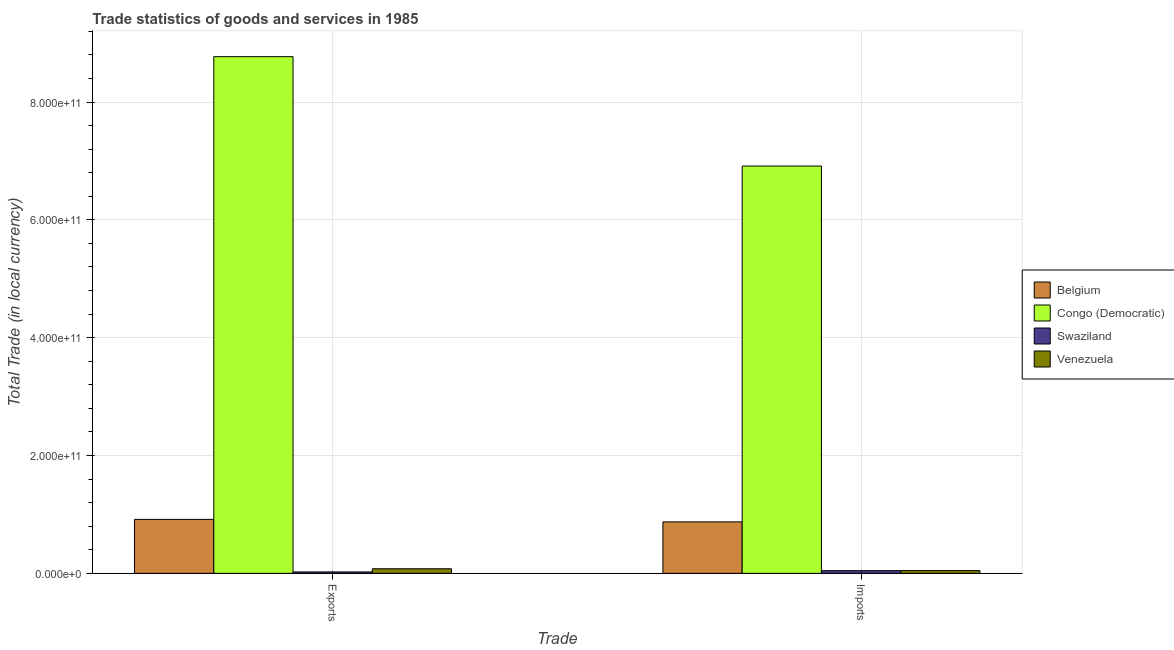How many different coloured bars are there?
Give a very brief answer. 4. How many bars are there on the 2nd tick from the right?
Your answer should be compact. 4. What is the label of the 2nd group of bars from the left?
Your answer should be compact. Imports. What is the imports of goods and services in Swaziland?
Keep it short and to the point. 4.54e+09. Across all countries, what is the maximum imports of goods and services?
Ensure brevity in your answer.  6.91e+11. Across all countries, what is the minimum imports of goods and services?
Offer a terse response. 4.54e+09. In which country was the export of goods and services maximum?
Provide a succinct answer. Congo (Democratic). In which country was the export of goods and services minimum?
Your answer should be compact. Swaziland. What is the total imports of goods and services in the graph?
Offer a terse response. 7.88e+11. What is the difference between the imports of goods and services in Venezuela and that in Swaziland?
Ensure brevity in your answer.  9.42e+07. What is the difference between the export of goods and services in Venezuela and the imports of goods and services in Belgium?
Offer a very short reply. -7.96e+1. What is the average imports of goods and services per country?
Keep it short and to the point. 1.97e+11. What is the difference between the export of goods and services and imports of goods and services in Congo (Democratic)?
Give a very brief answer. 1.86e+11. What is the ratio of the export of goods and services in Belgium to that in Congo (Democratic)?
Provide a short and direct response. 0.1. Is the imports of goods and services in Congo (Democratic) less than that in Belgium?
Provide a succinct answer. No. In how many countries, is the export of goods and services greater than the average export of goods and services taken over all countries?
Provide a short and direct response. 1. What does the 1st bar from the left in Imports represents?
Make the answer very short. Belgium. What does the 1st bar from the right in Exports represents?
Your response must be concise. Venezuela. How many bars are there?
Provide a succinct answer. 8. Are all the bars in the graph horizontal?
Your answer should be compact. No. How many countries are there in the graph?
Give a very brief answer. 4. What is the difference between two consecutive major ticks on the Y-axis?
Make the answer very short. 2.00e+11. Does the graph contain any zero values?
Offer a terse response. No. Does the graph contain grids?
Make the answer very short. Yes. How are the legend labels stacked?
Give a very brief answer. Vertical. What is the title of the graph?
Your answer should be very brief. Trade statistics of goods and services in 1985. Does "Latvia" appear as one of the legend labels in the graph?
Ensure brevity in your answer.  No. What is the label or title of the X-axis?
Offer a terse response. Trade. What is the label or title of the Y-axis?
Keep it short and to the point. Total Trade (in local currency). What is the Total Trade (in local currency) of Belgium in Exports?
Provide a short and direct response. 9.15e+1. What is the Total Trade (in local currency) in Congo (Democratic) in Exports?
Keep it short and to the point. 8.77e+11. What is the Total Trade (in local currency) in Swaziland in Exports?
Keep it short and to the point. 2.37e+09. What is the Total Trade (in local currency) in Venezuela in Exports?
Keep it short and to the point. 7.75e+09. What is the Total Trade (in local currency) in Belgium in Imports?
Make the answer very short. 8.74e+1. What is the Total Trade (in local currency) in Congo (Democratic) in Imports?
Your answer should be very brief. 6.91e+11. What is the Total Trade (in local currency) in Swaziland in Imports?
Provide a short and direct response. 4.54e+09. What is the Total Trade (in local currency) in Venezuela in Imports?
Provide a succinct answer. 4.63e+09. Across all Trade, what is the maximum Total Trade (in local currency) in Belgium?
Your response must be concise. 9.15e+1. Across all Trade, what is the maximum Total Trade (in local currency) in Congo (Democratic)?
Provide a short and direct response. 8.77e+11. Across all Trade, what is the maximum Total Trade (in local currency) of Swaziland?
Ensure brevity in your answer.  4.54e+09. Across all Trade, what is the maximum Total Trade (in local currency) in Venezuela?
Ensure brevity in your answer.  7.75e+09. Across all Trade, what is the minimum Total Trade (in local currency) of Belgium?
Give a very brief answer. 8.74e+1. Across all Trade, what is the minimum Total Trade (in local currency) in Congo (Democratic)?
Provide a short and direct response. 6.91e+11. Across all Trade, what is the minimum Total Trade (in local currency) of Swaziland?
Your answer should be compact. 2.37e+09. Across all Trade, what is the minimum Total Trade (in local currency) in Venezuela?
Offer a very short reply. 4.63e+09. What is the total Total Trade (in local currency) of Belgium in the graph?
Your answer should be compact. 1.79e+11. What is the total Total Trade (in local currency) in Congo (Democratic) in the graph?
Provide a succinct answer. 1.57e+12. What is the total Total Trade (in local currency) in Swaziland in the graph?
Provide a short and direct response. 6.91e+09. What is the total Total Trade (in local currency) of Venezuela in the graph?
Your answer should be compact. 1.24e+1. What is the difference between the Total Trade (in local currency) in Belgium in Exports and that in Imports?
Ensure brevity in your answer.  4.17e+09. What is the difference between the Total Trade (in local currency) in Congo (Democratic) in Exports and that in Imports?
Your response must be concise. 1.86e+11. What is the difference between the Total Trade (in local currency) of Swaziland in Exports and that in Imports?
Offer a very short reply. -2.17e+09. What is the difference between the Total Trade (in local currency) in Venezuela in Exports and that in Imports?
Keep it short and to the point. 3.11e+09. What is the difference between the Total Trade (in local currency) in Belgium in Exports and the Total Trade (in local currency) in Congo (Democratic) in Imports?
Provide a short and direct response. -6.00e+11. What is the difference between the Total Trade (in local currency) in Belgium in Exports and the Total Trade (in local currency) in Swaziland in Imports?
Offer a very short reply. 8.70e+1. What is the difference between the Total Trade (in local currency) in Belgium in Exports and the Total Trade (in local currency) in Venezuela in Imports?
Keep it short and to the point. 8.69e+1. What is the difference between the Total Trade (in local currency) of Congo (Democratic) in Exports and the Total Trade (in local currency) of Swaziland in Imports?
Provide a short and direct response. 8.72e+11. What is the difference between the Total Trade (in local currency) in Congo (Democratic) in Exports and the Total Trade (in local currency) in Venezuela in Imports?
Keep it short and to the point. 8.72e+11. What is the difference between the Total Trade (in local currency) of Swaziland in Exports and the Total Trade (in local currency) of Venezuela in Imports?
Ensure brevity in your answer.  -2.26e+09. What is the average Total Trade (in local currency) in Belgium per Trade?
Provide a succinct answer. 8.95e+1. What is the average Total Trade (in local currency) in Congo (Democratic) per Trade?
Make the answer very short. 7.84e+11. What is the average Total Trade (in local currency) of Swaziland per Trade?
Make the answer very short. 3.45e+09. What is the average Total Trade (in local currency) in Venezuela per Trade?
Provide a succinct answer. 6.19e+09. What is the difference between the Total Trade (in local currency) in Belgium and Total Trade (in local currency) in Congo (Democratic) in Exports?
Ensure brevity in your answer.  -7.85e+11. What is the difference between the Total Trade (in local currency) of Belgium and Total Trade (in local currency) of Swaziland in Exports?
Offer a very short reply. 8.92e+1. What is the difference between the Total Trade (in local currency) of Belgium and Total Trade (in local currency) of Venezuela in Exports?
Keep it short and to the point. 8.38e+1. What is the difference between the Total Trade (in local currency) of Congo (Democratic) and Total Trade (in local currency) of Swaziland in Exports?
Your answer should be compact. 8.75e+11. What is the difference between the Total Trade (in local currency) of Congo (Democratic) and Total Trade (in local currency) of Venezuela in Exports?
Your answer should be very brief. 8.69e+11. What is the difference between the Total Trade (in local currency) of Swaziland and Total Trade (in local currency) of Venezuela in Exports?
Provide a succinct answer. -5.38e+09. What is the difference between the Total Trade (in local currency) of Belgium and Total Trade (in local currency) of Congo (Democratic) in Imports?
Provide a short and direct response. -6.04e+11. What is the difference between the Total Trade (in local currency) in Belgium and Total Trade (in local currency) in Swaziland in Imports?
Your response must be concise. 8.28e+1. What is the difference between the Total Trade (in local currency) in Belgium and Total Trade (in local currency) in Venezuela in Imports?
Keep it short and to the point. 8.27e+1. What is the difference between the Total Trade (in local currency) of Congo (Democratic) and Total Trade (in local currency) of Swaziland in Imports?
Offer a very short reply. 6.87e+11. What is the difference between the Total Trade (in local currency) of Congo (Democratic) and Total Trade (in local currency) of Venezuela in Imports?
Offer a terse response. 6.87e+11. What is the difference between the Total Trade (in local currency) in Swaziland and Total Trade (in local currency) in Venezuela in Imports?
Provide a succinct answer. -9.42e+07. What is the ratio of the Total Trade (in local currency) in Belgium in Exports to that in Imports?
Your answer should be compact. 1.05. What is the ratio of the Total Trade (in local currency) of Congo (Democratic) in Exports to that in Imports?
Offer a very short reply. 1.27. What is the ratio of the Total Trade (in local currency) of Swaziland in Exports to that in Imports?
Make the answer very short. 0.52. What is the ratio of the Total Trade (in local currency) of Venezuela in Exports to that in Imports?
Your answer should be very brief. 1.67. What is the difference between the highest and the second highest Total Trade (in local currency) in Belgium?
Your response must be concise. 4.17e+09. What is the difference between the highest and the second highest Total Trade (in local currency) of Congo (Democratic)?
Your answer should be very brief. 1.86e+11. What is the difference between the highest and the second highest Total Trade (in local currency) in Swaziland?
Your response must be concise. 2.17e+09. What is the difference between the highest and the second highest Total Trade (in local currency) in Venezuela?
Your answer should be compact. 3.11e+09. What is the difference between the highest and the lowest Total Trade (in local currency) in Belgium?
Provide a succinct answer. 4.17e+09. What is the difference between the highest and the lowest Total Trade (in local currency) of Congo (Democratic)?
Your answer should be very brief. 1.86e+11. What is the difference between the highest and the lowest Total Trade (in local currency) in Swaziland?
Make the answer very short. 2.17e+09. What is the difference between the highest and the lowest Total Trade (in local currency) in Venezuela?
Provide a succinct answer. 3.11e+09. 